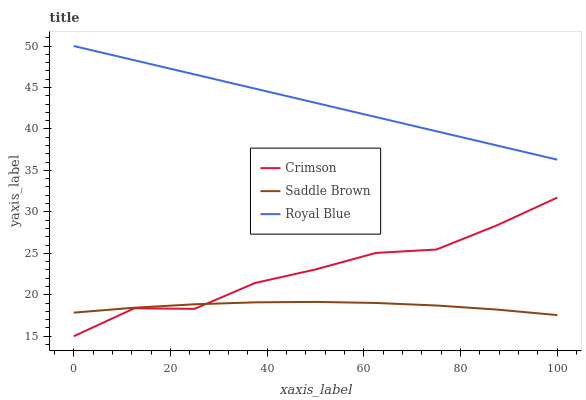Does Saddle Brown have the minimum area under the curve?
Answer yes or no. Yes. Does Royal Blue have the maximum area under the curve?
Answer yes or no. Yes. Does Royal Blue have the minimum area under the curve?
Answer yes or no. No. Does Saddle Brown have the maximum area under the curve?
Answer yes or no. No. Is Royal Blue the smoothest?
Answer yes or no. Yes. Is Crimson the roughest?
Answer yes or no. Yes. Is Saddle Brown the smoothest?
Answer yes or no. No. Is Saddle Brown the roughest?
Answer yes or no. No. Does Crimson have the lowest value?
Answer yes or no. Yes. Does Saddle Brown have the lowest value?
Answer yes or no. No. Does Royal Blue have the highest value?
Answer yes or no. Yes. Does Saddle Brown have the highest value?
Answer yes or no. No. Is Saddle Brown less than Royal Blue?
Answer yes or no. Yes. Is Royal Blue greater than Saddle Brown?
Answer yes or no. Yes. Does Crimson intersect Saddle Brown?
Answer yes or no. Yes. Is Crimson less than Saddle Brown?
Answer yes or no. No. Is Crimson greater than Saddle Brown?
Answer yes or no. No. Does Saddle Brown intersect Royal Blue?
Answer yes or no. No. 